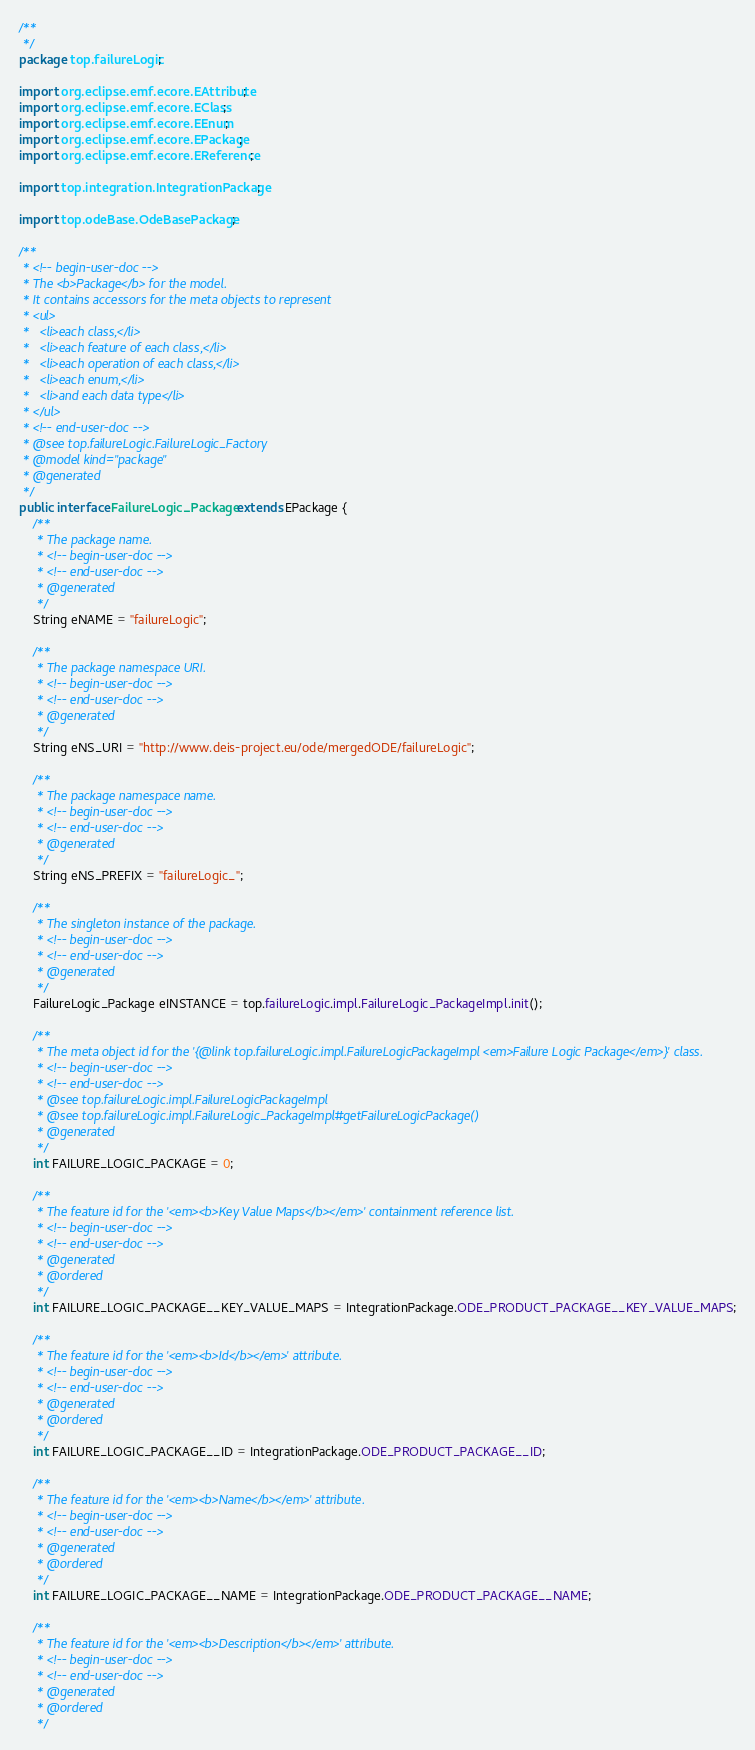Convert code to text. <code><loc_0><loc_0><loc_500><loc_500><_Java_>/**
 */
package top.failureLogic;

import org.eclipse.emf.ecore.EAttribute;
import org.eclipse.emf.ecore.EClass;
import org.eclipse.emf.ecore.EEnum;
import org.eclipse.emf.ecore.EPackage;
import org.eclipse.emf.ecore.EReference;

import top.integration.IntegrationPackage;

import top.odeBase.OdeBasePackage;

/**
 * <!-- begin-user-doc -->
 * The <b>Package</b> for the model.
 * It contains accessors for the meta objects to represent
 * <ul>
 *   <li>each class,</li>
 *   <li>each feature of each class,</li>
 *   <li>each operation of each class,</li>
 *   <li>each enum,</li>
 *   <li>and each data type</li>
 * </ul>
 * <!-- end-user-doc -->
 * @see top.failureLogic.FailureLogic_Factory
 * @model kind="package"
 * @generated
 */
public interface FailureLogic_Package extends EPackage {
	/**
	 * The package name.
	 * <!-- begin-user-doc -->
	 * <!-- end-user-doc -->
	 * @generated
	 */
	String eNAME = "failureLogic";

	/**
	 * The package namespace URI.
	 * <!-- begin-user-doc -->
	 * <!-- end-user-doc -->
	 * @generated
	 */
	String eNS_URI = "http://www.deis-project.eu/ode/mergedODE/failureLogic";

	/**
	 * The package namespace name.
	 * <!-- begin-user-doc -->
	 * <!-- end-user-doc -->
	 * @generated
	 */
	String eNS_PREFIX = "failureLogic_";

	/**
	 * The singleton instance of the package.
	 * <!-- begin-user-doc -->
	 * <!-- end-user-doc -->
	 * @generated
	 */
	FailureLogic_Package eINSTANCE = top.failureLogic.impl.FailureLogic_PackageImpl.init();

	/**
	 * The meta object id for the '{@link top.failureLogic.impl.FailureLogicPackageImpl <em>Failure Logic Package</em>}' class.
	 * <!-- begin-user-doc -->
	 * <!-- end-user-doc -->
	 * @see top.failureLogic.impl.FailureLogicPackageImpl
	 * @see top.failureLogic.impl.FailureLogic_PackageImpl#getFailureLogicPackage()
	 * @generated
	 */
	int FAILURE_LOGIC_PACKAGE = 0;

	/**
	 * The feature id for the '<em><b>Key Value Maps</b></em>' containment reference list.
	 * <!-- begin-user-doc -->
	 * <!-- end-user-doc -->
	 * @generated
	 * @ordered
	 */
	int FAILURE_LOGIC_PACKAGE__KEY_VALUE_MAPS = IntegrationPackage.ODE_PRODUCT_PACKAGE__KEY_VALUE_MAPS;

	/**
	 * The feature id for the '<em><b>Id</b></em>' attribute.
	 * <!-- begin-user-doc -->
	 * <!-- end-user-doc -->
	 * @generated
	 * @ordered
	 */
	int FAILURE_LOGIC_PACKAGE__ID = IntegrationPackage.ODE_PRODUCT_PACKAGE__ID;

	/**
	 * The feature id for the '<em><b>Name</b></em>' attribute.
	 * <!-- begin-user-doc -->
	 * <!-- end-user-doc -->
	 * @generated
	 * @ordered
	 */
	int FAILURE_LOGIC_PACKAGE__NAME = IntegrationPackage.ODE_PRODUCT_PACKAGE__NAME;

	/**
	 * The feature id for the '<em><b>Description</b></em>' attribute.
	 * <!-- begin-user-doc -->
	 * <!-- end-user-doc -->
	 * @generated
	 * @ordered
	 */</code> 